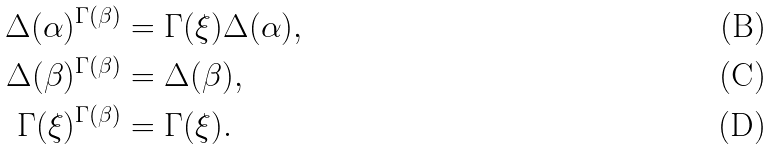<formula> <loc_0><loc_0><loc_500><loc_500>\Delta ( \alpha ) ^ { \Gamma ( \beta ) } & = \Gamma ( \xi ) \Delta ( \alpha ) , \\ \Delta ( \beta ) ^ { \Gamma ( \beta ) } & = \Delta ( \beta ) , \\ \Gamma ( \xi ) ^ { \Gamma ( \beta ) } & = \Gamma ( \xi ) .</formula> 